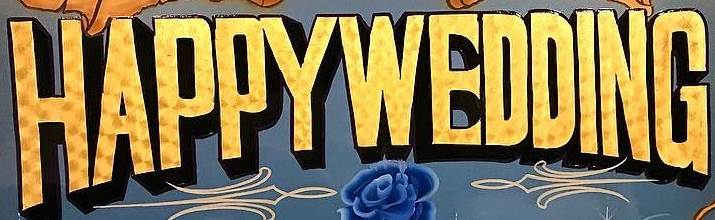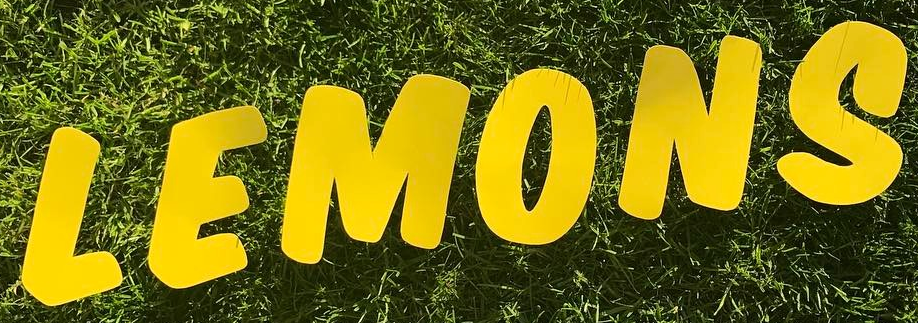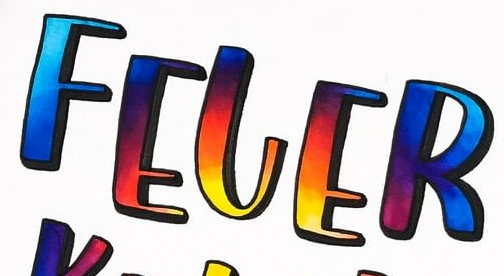Read the text from these images in sequence, separated by a semicolon. HAPPYWEDDING; LEMONS; FELER 